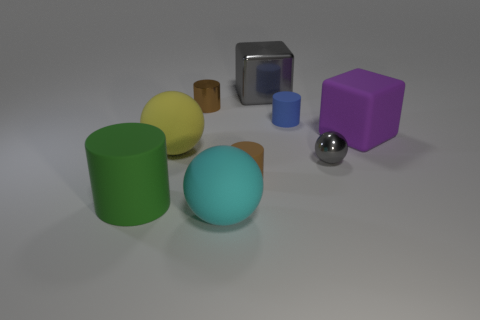Is the tiny sphere the same color as the big shiny object?
Your answer should be compact. Yes. There is a matte sphere behind the small brown cylinder to the right of the cyan object; is there a big yellow matte object that is in front of it?
Offer a terse response. No. Does the tiny cylinder in front of the yellow rubber sphere have the same color as the small shiny cylinder?
Ensure brevity in your answer.  Yes. How many cylinders are gray metal things or small matte things?
Your answer should be compact. 2. What shape is the gray thing that is behind the small brown object behind the gray sphere?
Make the answer very short. Cube. What size is the cylinder that is in front of the tiny brown cylinder in front of the large matte object right of the tiny blue cylinder?
Your answer should be very brief. Large. Does the brown metal thing have the same size as the cyan matte thing?
Provide a succinct answer. No. What number of objects are blue matte objects or big cyan objects?
Make the answer very short. 2. There is a rubber ball behind the large rubber object in front of the green thing; what size is it?
Your answer should be very brief. Large. What size is the gray metallic block?
Offer a very short reply. Large. 